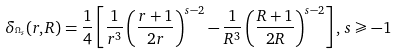<formula> <loc_0><loc_0><loc_500><loc_500>\delta _ { ^ { \Omega _ { s } } } ( r , R ) = \frac { 1 } { 4 } \left [ { \frac { 1 } { r ^ { 3 } } \left ( { \frac { r + 1 } { 2 r } } \right ) ^ { s - 2 } - \frac { 1 } { R ^ { 3 } } \left ( { \frac { R + 1 } { 2 R } } \right ) ^ { s - 2 } } \right ] , \, s \geqslant - 1</formula> 